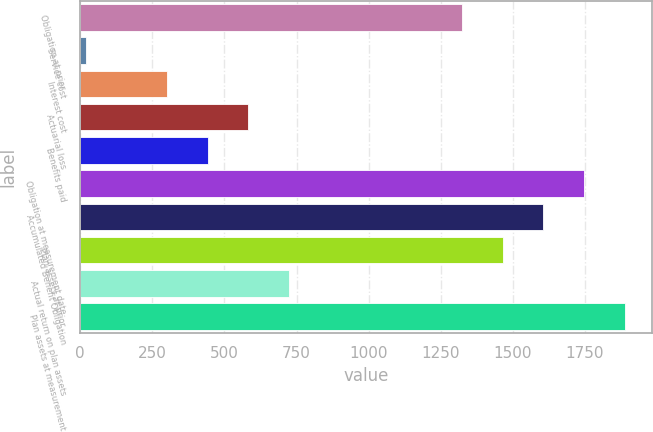<chart> <loc_0><loc_0><loc_500><loc_500><bar_chart><fcel>Obligation at prior<fcel>Service cost<fcel>Interest cost<fcel>Actuarial loss<fcel>Benefits paid<fcel>Obligation at measurement date<fcel>Accumulated Benefit Obligation<fcel>Plan assets at prior<fcel>Actual return on plan assets<fcel>Plan assets at measurement<nl><fcel>1323<fcel>19<fcel>301<fcel>583<fcel>442<fcel>1746<fcel>1605<fcel>1464<fcel>724<fcel>1887<nl></chart> 